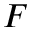Convert formula to latex. <formula><loc_0><loc_0><loc_500><loc_500>F</formula> 